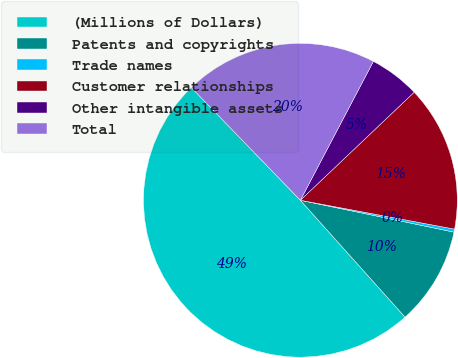Convert chart. <chart><loc_0><loc_0><loc_500><loc_500><pie_chart><fcel>(Millions of Dollars)<fcel>Patents and copyrights<fcel>Trade names<fcel>Customer relationships<fcel>Other intangible assets<fcel>Total<nl><fcel>49.39%<fcel>10.12%<fcel>0.31%<fcel>15.03%<fcel>5.21%<fcel>19.94%<nl></chart> 